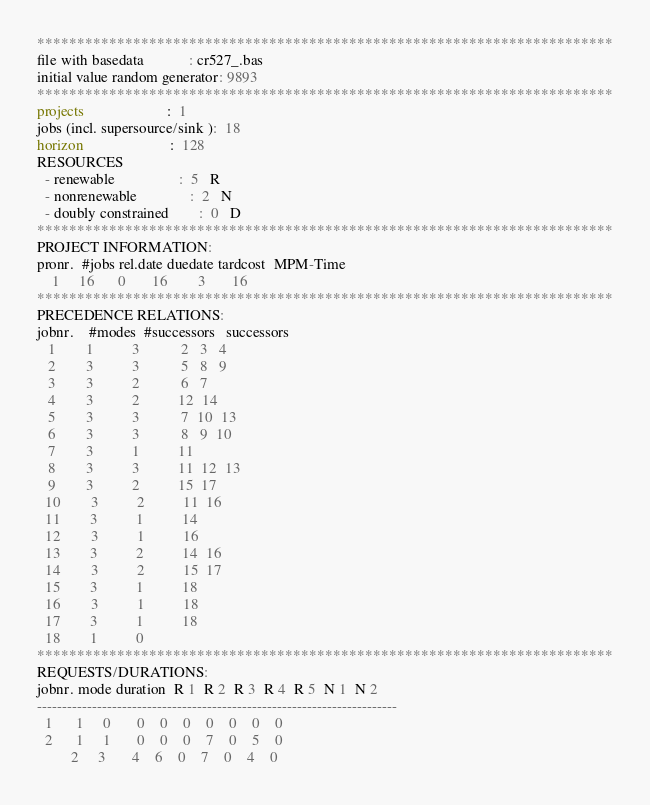<code> <loc_0><loc_0><loc_500><loc_500><_ObjectiveC_>************************************************************************
file with basedata            : cr527_.bas
initial value random generator: 9893
************************************************************************
projects                      :  1
jobs (incl. supersource/sink ):  18
horizon                       :  128
RESOURCES
  - renewable                 :  5   R
  - nonrenewable              :  2   N
  - doubly constrained        :  0   D
************************************************************************
PROJECT INFORMATION:
pronr.  #jobs rel.date duedate tardcost  MPM-Time
    1     16      0       16        3       16
************************************************************************
PRECEDENCE RELATIONS:
jobnr.    #modes  #successors   successors
   1        1          3           2   3   4
   2        3          3           5   8   9
   3        3          2           6   7
   4        3          2          12  14
   5        3          3           7  10  13
   6        3          3           8   9  10
   7        3          1          11
   8        3          3          11  12  13
   9        3          2          15  17
  10        3          2          11  16
  11        3          1          14
  12        3          1          16
  13        3          2          14  16
  14        3          2          15  17
  15        3          1          18
  16        3          1          18
  17        3          1          18
  18        1          0        
************************************************************************
REQUESTS/DURATIONS:
jobnr. mode duration  R 1  R 2  R 3  R 4  R 5  N 1  N 2
------------------------------------------------------------------------
  1      1     0       0    0    0    0    0    0    0
  2      1     1       0    0    0    7    0    5    0
         2     3       4    6    0    7    0    4    0</code> 